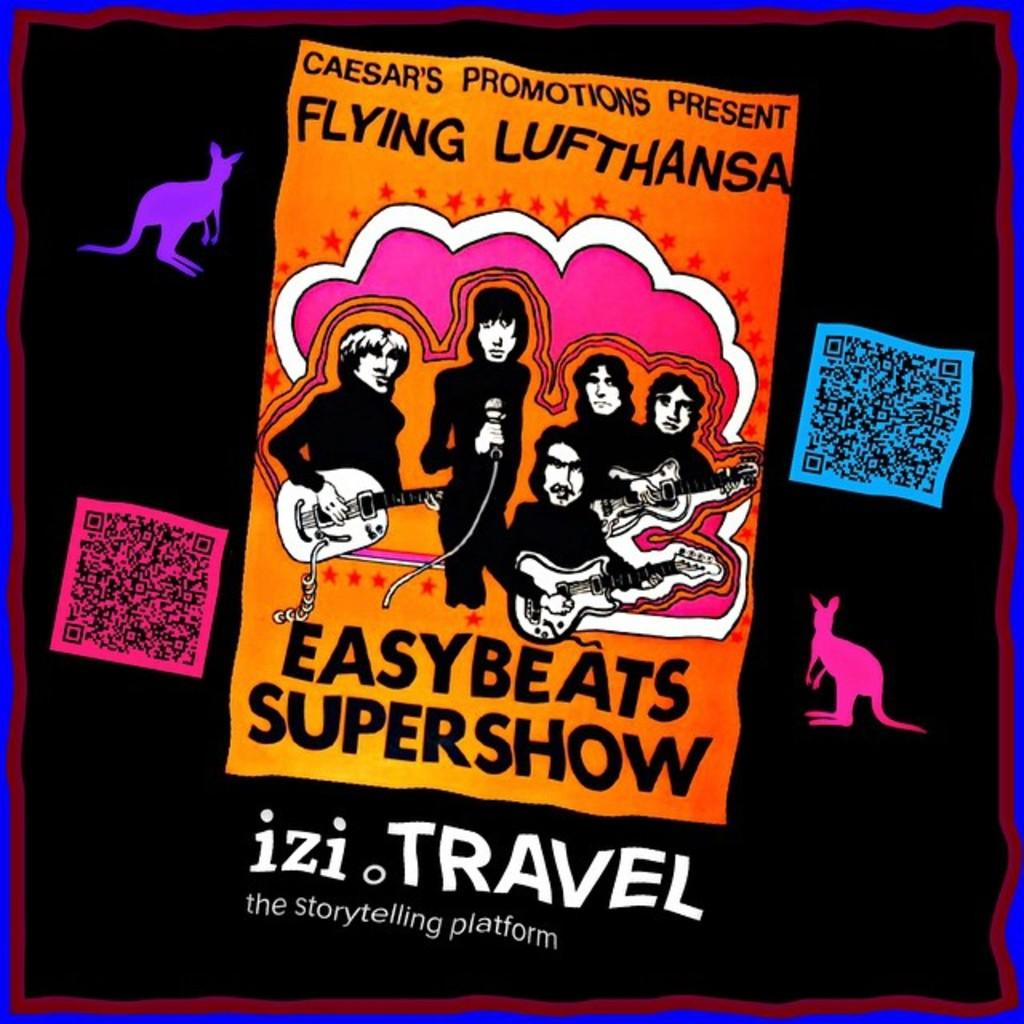What type of visual might the image be? The image might be a poster. What can be found in the image besides visual elements? There is text in the image. Who or what is depicted in the image? There are people and animals in the image. What object can be seen in the image that is typically associated with music? There is a guitar in the image. How many doors can be seen in the image? There are no doors visible in the image. What type of body is depicted in the image? There is no specific body depicted in the image; it features people and animals in general. 